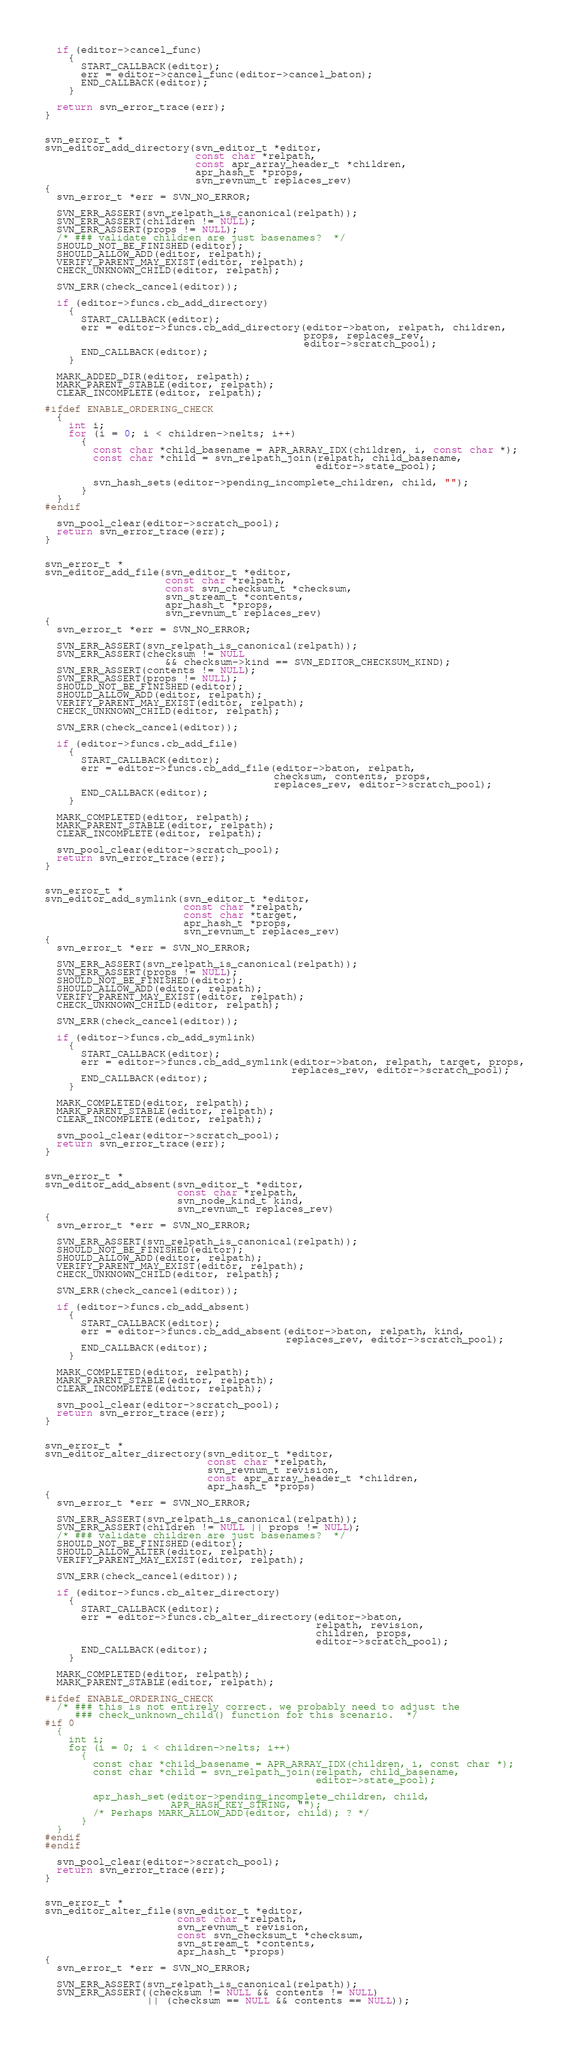<code> <loc_0><loc_0><loc_500><loc_500><_C_>  if (editor->cancel_func)
    {
      START_CALLBACK(editor);
      err = editor->cancel_func(editor->cancel_baton);
      END_CALLBACK(editor);
    }

  return svn_error_trace(err);
}


svn_error_t *
svn_editor_add_directory(svn_editor_t *editor,
                         const char *relpath,
                         const apr_array_header_t *children,
                         apr_hash_t *props,
                         svn_revnum_t replaces_rev)
{
  svn_error_t *err = SVN_NO_ERROR;

  SVN_ERR_ASSERT(svn_relpath_is_canonical(relpath));
  SVN_ERR_ASSERT(children != NULL);
  SVN_ERR_ASSERT(props != NULL);
  /* ### validate children are just basenames?  */
  SHOULD_NOT_BE_FINISHED(editor);
  SHOULD_ALLOW_ADD(editor, relpath);
  VERIFY_PARENT_MAY_EXIST(editor, relpath);
  CHECK_UNKNOWN_CHILD(editor, relpath);

  SVN_ERR(check_cancel(editor));

  if (editor->funcs.cb_add_directory)
    {
      START_CALLBACK(editor);
      err = editor->funcs.cb_add_directory(editor->baton, relpath, children,
                                           props, replaces_rev,
                                           editor->scratch_pool);
      END_CALLBACK(editor);
    }

  MARK_ADDED_DIR(editor, relpath);
  MARK_PARENT_STABLE(editor, relpath);
  CLEAR_INCOMPLETE(editor, relpath);

#ifdef ENABLE_ORDERING_CHECK
  {
    int i;
    for (i = 0; i < children->nelts; i++)
      {
        const char *child_basename = APR_ARRAY_IDX(children, i, const char *);
        const char *child = svn_relpath_join(relpath, child_basename,
                                             editor->state_pool);

        svn_hash_sets(editor->pending_incomplete_children, child, "");
      }
  }
#endif

  svn_pool_clear(editor->scratch_pool);
  return svn_error_trace(err);
}


svn_error_t *
svn_editor_add_file(svn_editor_t *editor,
                    const char *relpath,
                    const svn_checksum_t *checksum,
                    svn_stream_t *contents,
                    apr_hash_t *props,
                    svn_revnum_t replaces_rev)
{
  svn_error_t *err = SVN_NO_ERROR;

  SVN_ERR_ASSERT(svn_relpath_is_canonical(relpath));
  SVN_ERR_ASSERT(checksum != NULL
                    && checksum->kind == SVN_EDITOR_CHECKSUM_KIND);
  SVN_ERR_ASSERT(contents != NULL);
  SVN_ERR_ASSERT(props != NULL);
  SHOULD_NOT_BE_FINISHED(editor);
  SHOULD_ALLOW_ADD(editor, relpath);
  VERIFY_PARENT_MAY_EXIST(editor, relpath);
  CHECK_UNKNOWN_CHILD(editor, relpath);

  SVN_ERR(check_cancel(editor));

  if (editor->funcs.cb_add_file)
    {
      START_CALLBACK(editor);
      err = editor->funcs.cb_add_file(editor->baton, relpath,
                                      checksum, contents, props,
                                      replaces_rev, editor->scratch_pool);
      END_CALLBACK(editor);
    }

  MARK_COMPLETED(editor, relpath);
  MARK_PARENT_STABLE(editor, relpath);
  CLEAR_INCOMPLETE(editor, relpath);

  svn_pool_clear(editor->scratch_pool);
  return svn_error_trace(err);
}


svn_error_t *
svn_editor_add_symlink(svn_editor_t *editor,
                       const char *relpath,
                       const char *target,
                       apr_hash_t *props,
                       svn_revnum_t replaces_rev)
{
  svn_error_t *err = SVN_NO_ERROR;

  SVN_ERR_ASSERT(svn_relpath_is_canonical(relpath));
  SVN_ERR_ASSERT(props != NULL);
  SHOULD_NOT_BE_FINISHED(editor);
  SHOULD_ALLOW_ADD(editor, relpath);
  VERIFY_PARENT_MAY_EXIST(editor, relpath);
  CHECK_UNKNOWN_CHILD(editor, relpath);

  SVN_ERR(check_cancel(editor));

  if (editor->funcs.cb_add_symlink)
    {
      START_CALLBACK(editor);
      err = editor->funcs.cb_add_symlink(editor->baton, relpath, target, props,
                                         replaces_rev, editor->scratch_pool);
      END_CALLBACK(editor);
    }

  MARK_COMPLETED(editor, relpath);
  MARK_PARENT_STABLE(editor, relpath);
  CLEAR_INCOMPLETE(editor, relpath);

  svn_pool_clear(editor->scratch_pool);
  return svn_error_trace(err);
}


svn_error_t *
svn_editor_add_absent(svn_editor_t *editor,
                      const char *relpath,
                      svn_node_kind_t kind,
                      svn_revnum_t replaces_rev)
{
  svn_error_t *err = SVN_NO_ERROR;

  SVN_ERR_ASSERT(svn_relpath_is_canonical(relpath));
  SHOULD_NOT_BE_FINISHED(editor);
  SHOULD_ALLOW_ADD(editor, relpath);
  VERIFY_PARENT_MAY_EXIST(editor, relpath);
  CHECK_UNKNOWN_CHILD(editor, relpath);

  SVN_ERR(check_cancel(editor));

  if (editor->funcs.cb_add_absent)
    {
      START_CALLBACK(editor);
      err = editor->funcs.cb_add_absent(editor->baton, relpath, kind,
                                        replaces_rev, editor->scratch_pool);
      END_CALLBACK(editor);
    }

  MARK_COMPLETED(editor, relpath);
  MARK_PARENT_STABLE(editor, relpath);
  CLEAR_INCOMPLETE(editor, relpath);

  svn_pool_clear(editor->scratch_pool);
  return svn_error_trace(err);
}


svn_error_t *
svn_editor_alter_directory(svn_editor_t *editor,
                           const char *relpath,
                           svn_revnum_t revision,
                           const apr_array_header_t *children,
                           apr_hash_t *props)
{
  svn_error_t *err = SVN_NO_ERROR;

  SVN_ERR_ASSERT(svn_relpath_is_canonical(relpath));
  SVN_ERR_ASSERT(children != NULL || props != NULL);
  /* ### validate children are just basenames?  */
  SHOULD_NOT_BE_FINISHED(editor);
  SHOULD_ALLOW_ALTER(editor, relpath);
  VERIFY_PARENT_MAY_EXIST(editor, relpath);

  SVN_ERR(check_cancel(editor));

  if (editor->funcs.cb_alter_directory)
    {
      START_CALLBACK(editor);
      err = editor->funcs.cb_alter_directory(editor->baton,
                                             relpath, revision,
                                             children, props,
                                             editor->scratch_pool);
      END_CALLBACK(editor);
    }

  MARK_COMPLETED(editor, relpath);
  MARK_PARENT_STABLE(editor, relpath);

#ifdef ENABLE_ORDERING_CHECK
  /* ### this is not entirely correct. we probably need to adjust the
     ### check_unknown_child() function for this scenario.  */
#if 0
  {
    int i;
    for (i = 0; i < children->nelts; i++)
      {
        const char *child_basename = APR_ARRAY_IDX(children, i, const char *);
        const char *child = svn_relpath_join(relpath, child_basename,
                                             editor->state_pool);

        apr_hash_set(editor->pending_incomplete_children, child,
                     APR_HASH_KEY_STRING, "");
        /* Perhaps MARK_ALLOW_ADD(editor, child); ? */
      }
  }
#endif
#endif

  svn_pool_clear(editor->scratch_pool);
  return svn_error_trace(err);
}


svn_error_t *
svn_editor_alter_file(svn_editor_t *editor,
                      const char *relpath,
                      svn_revnum_t revision,
                      const svn_checksum_t *checksum,
                      svn_stream_t *contents,
                      apr_hash_t *props)
{
  svn_error_t *err = SVN_NO_ERROR;

  SVN_ERR_ASSERT(svn_relpath_is_canonical(relpath));
  SVN_ERR_ASSERT((checksum != NULL && contents != NULL)
                 || (checksum == NULL && contents == NULL));</code> 